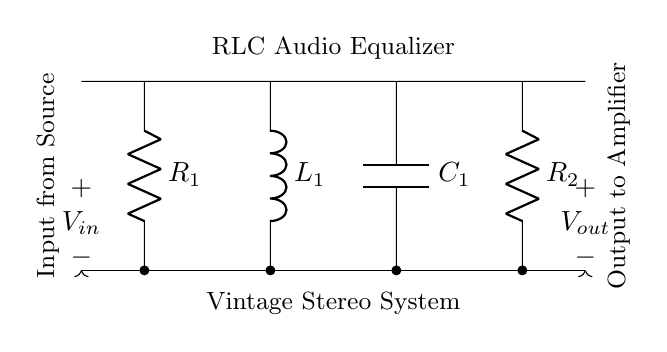What is the main purpose of this circuit? The main purpose of the circuit is to function as an audio equalizer, which modifies the frequency response of audio signals in a vintage stereo system.
Answer: audio equalizer How many resistors are present in the circuit? The circuit contains two resistors, as indicated by the components labeled R1 and R2.
Answer: two What component is connected in series with the capacitor? The inductor, represented by L1, is connected in series with the capacitor C1 in the circuit layout.
Answer: inductor What is the input signal labeled as? The input signal is labeled as V in, which indicates the incoming voltage from the audio source.
Answer: V in What type of circuit is this RLC circuit classified as? This RLC circuit is classified as a passive filter circuit, specifically tuned for equalization of audio frequencies.
Answer: passive filter Which component is responsible for storing electrical energy? The capacitor C1 is responsible for storing electrical energy in the circuit, allowing it to smooth out signal variations.
Answer: capacitor What is the output of this circuit directed towards? The output of the circuit is directed towards an amplifier, as indicated by the labeling on the output line.
Answer: amplifier 